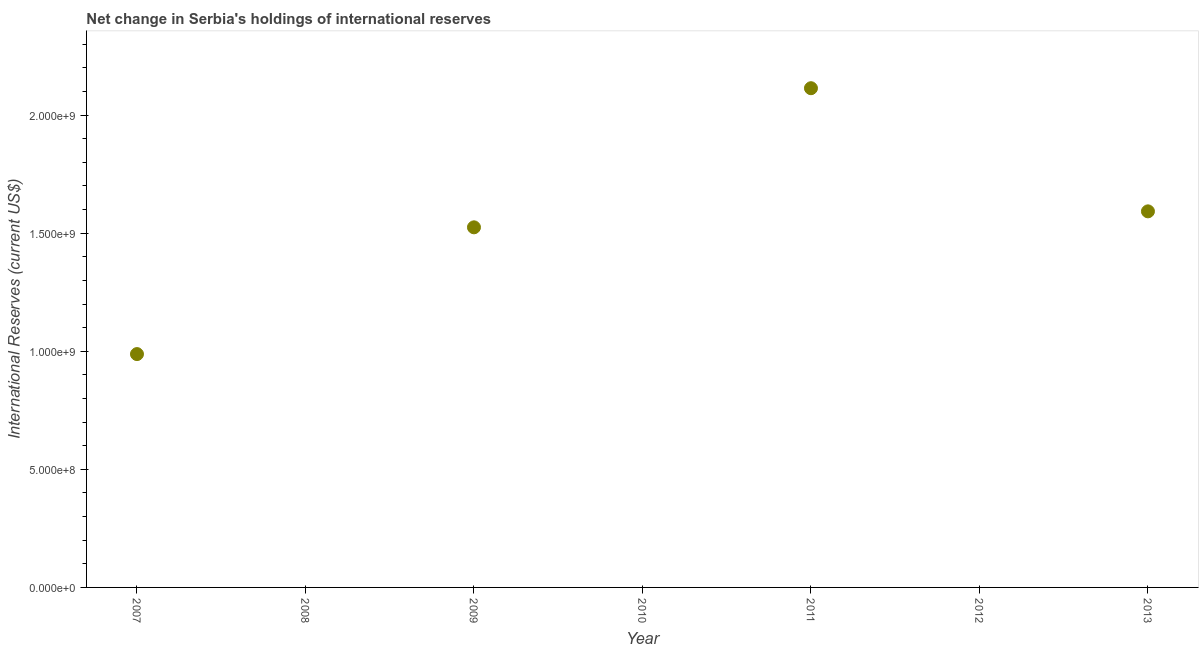Across all years, what is the maximum reserves and related items?
Make the answer very short. 2.11e+09. In which year was the reserves and related items maximum?
Ensure brevity in your answer.  2011. What is the sum of the reserves and related items?
Offer a terse response. 6.22e+09. What is the difference between the reserves and related items in 2007 and 2011?
Give a very brief answer. -1.13e+09. What is the average reserves and related items per year?
Keep it short and to the point. 8.88e+08. What is the median reserves and related items?
Your answer should be very brief. 9.88e+08. What is the ratio of the reserves and related items in 2009 to that in 2013?
Your response must be concise. 0.96. What is the difference between the highest and the second highest reserves and related items?
Make the answer very short. 5.21e+08. Is the sum of the reserves and related items in 2011 and 2013 greater than the maximum reserves and related items across all years?
Offer a terse response. Yes. What is the difference between the highest and the lowest reserves and related items?
Your response must be concise. 2.11e+09. Does the reserves and related items monotonically increase over the years?
Ensure brevity in your answer.  No. How many dotlines are there?
Your answer should be compact. 1. Are the values on the major ticks of Y-axis written in scientific E-notation?
Ensure brevity in your answer.  Yes. Does the graph contain any zero values?
Ensure brevity in your answer.  Yes. What is the title of the graph?
Your response must be concise. Net change in Serbia's holdings of international reserves. What is the label or title of the X-axis?
Your response must be concise. Year. What is the label or title of the Y-axis?
Give a very brief answer. International Reserves (current US$). What is the International Reserves (current US$) in 2007?
Ensure brevity in your answer.  9.88e+08. What is the International Reserves (current US$) in 2009?
Your answer should be compact. 1.52e+09. What is the International Reserves (current US$) in 2010?
Keep it short and to the point. 0. What is the International Reserves (current US$) in 2011?
Offer a very short reply. 2.11e+09. What is the International Reserves (current US$) in 2013?
Provide a succinct answer. 1.59e+09. What is the difference between the International Reserves (current US$) in 2007 and 2009?
Offer a terse response. -5.37e+08. What is the difference between the International Reserves (current US$) in 2007 and 2011?
Provide a short and direct response. -1.13e+09. What is the difference between the International Reserves (current US$) in 2007 and 2013?
Your answer should be compact. -6.04e+08. What is the difference between the International Reserves (current US$) in 2009 and 2011?
Provide a short and direct response. -5.89e+08. What is the difference between the International Reserves (current US$) in 2009 and 2013?
Your response must be concise. -6.76e+07. What is the difference between the International Reserves (current US$) in 2011 and 2013?
Provide a short and direct response. 5.21e+08. What is the ratio of the International Reserves (current US$) in 2007 to that in 2009?
Make the answer very short. 0.65. What is the ratio of the International Reserves (current US$) in 2007 to that in 2011?
Keep it short and to the point. 0.47. What is the ratio of the International Reserves (current US$) in 2007 to that in 2013?
Provide a short and direct response. 0.62. What is the ratio of the International Reserves (current US$) in 2009 to that in 2011?
Offer a very short reply. 0.72. What is the ratio of the International Reserves (current US$) in 2009 to that in 2013?
Your answer should be compact. 0.96. What is the ratio of the International Reserves (current US$) in 2011 to that in 2013?
Your response must be concise. 1.33. 